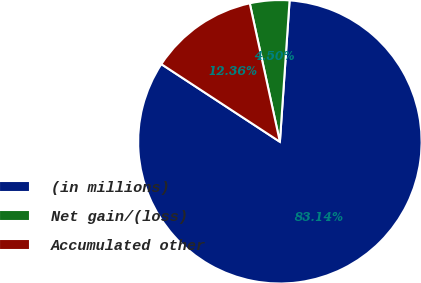Convert chart to OTSL. <chart><loc_0><loc_0><loc_500><loc_500><pie_chart><fcel>(in millions)<fcel>Net gain/(loss)<fcel>Accumulated other<nl><fcel>83.14%<fcel>4.5%<fcel>12.36%<nl></chart> 